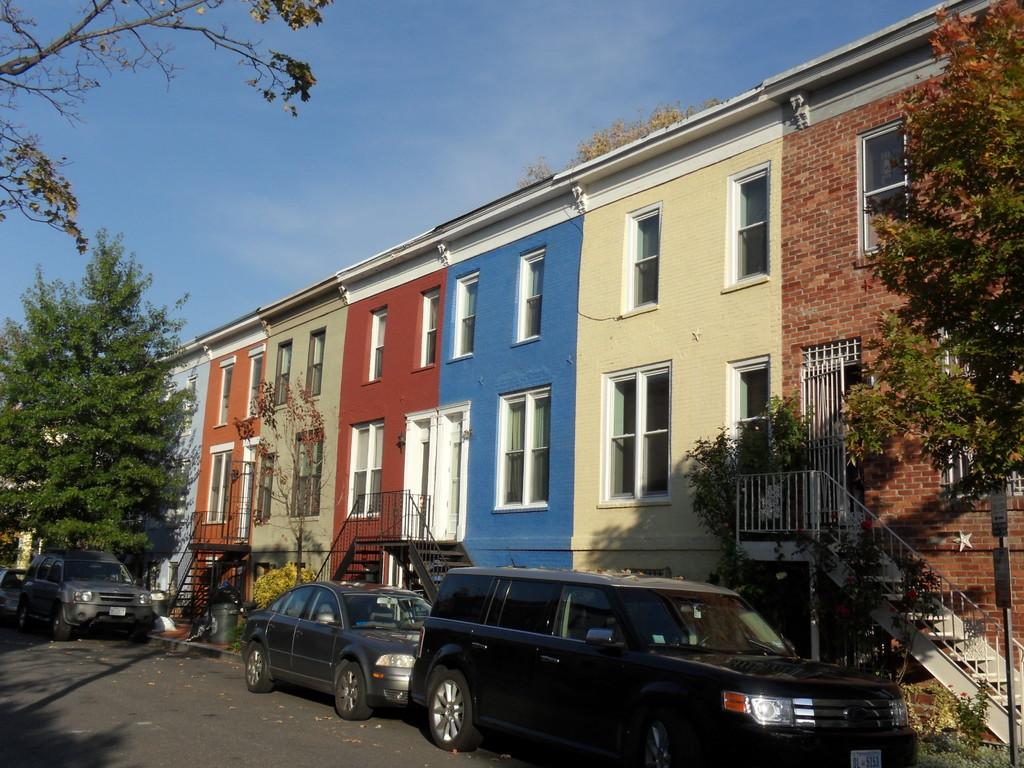What type of structures are present in the image? There are buildings in the image. What features can be seen on the buildings? The buildings have windows, doors, stairs, and railings. What can be seen on the ground in the image? The ground is visible in the image, along with trees, poles, boards, and vehicles. What is the condition of the sky in the image? The sky is visible in the image, and there are clouds present. Can you describe the argument taking place at the table in the image? There is no table or argument present in the image. How many cents are visible on the ground in the image? There are no cents visible on the ground in the image. 